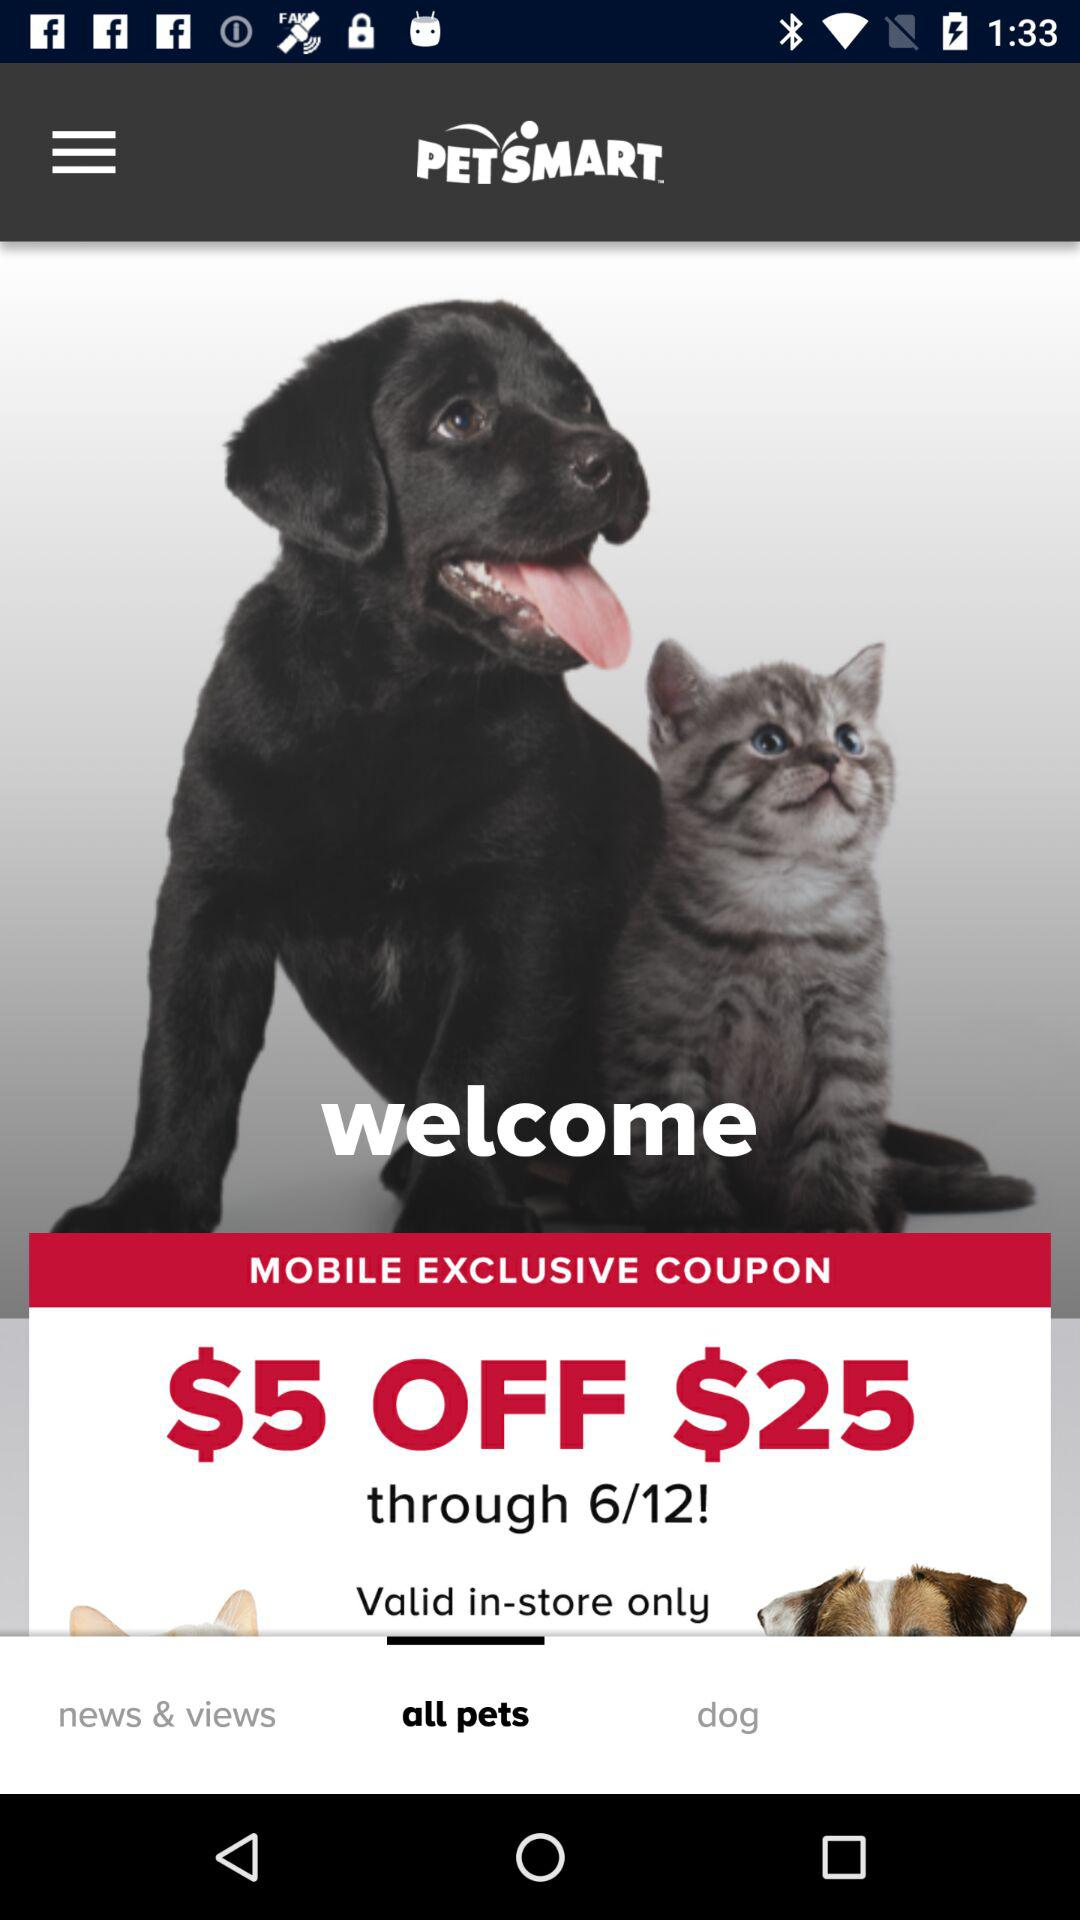What is the amount of the discount?
Answer the question using a single word or phrase. $5 